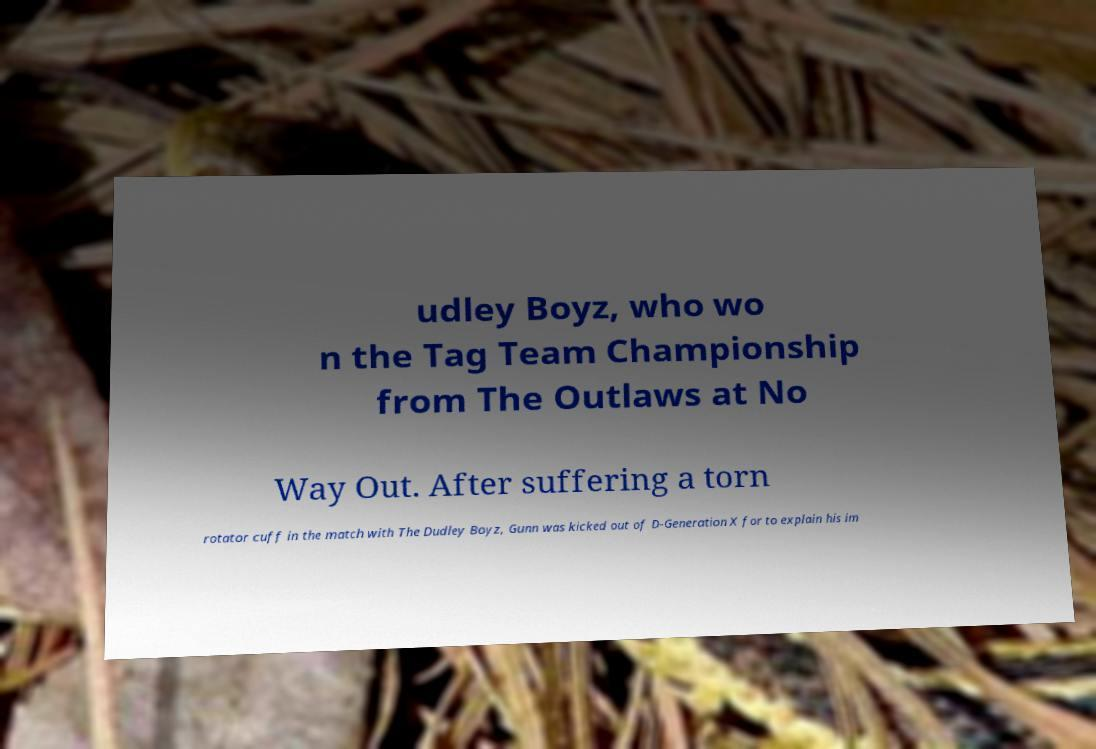There's text embedded in this image that I need extracted. Can you transcribe it verbatim? udley Boyz, who wo n the Tag Team Championship from The Outlaws at No Way Out. After suffering a torn rotator cuff in the match with The Dudley Boyz, Gunn was kicked out of D-Generation X for to explain his im 